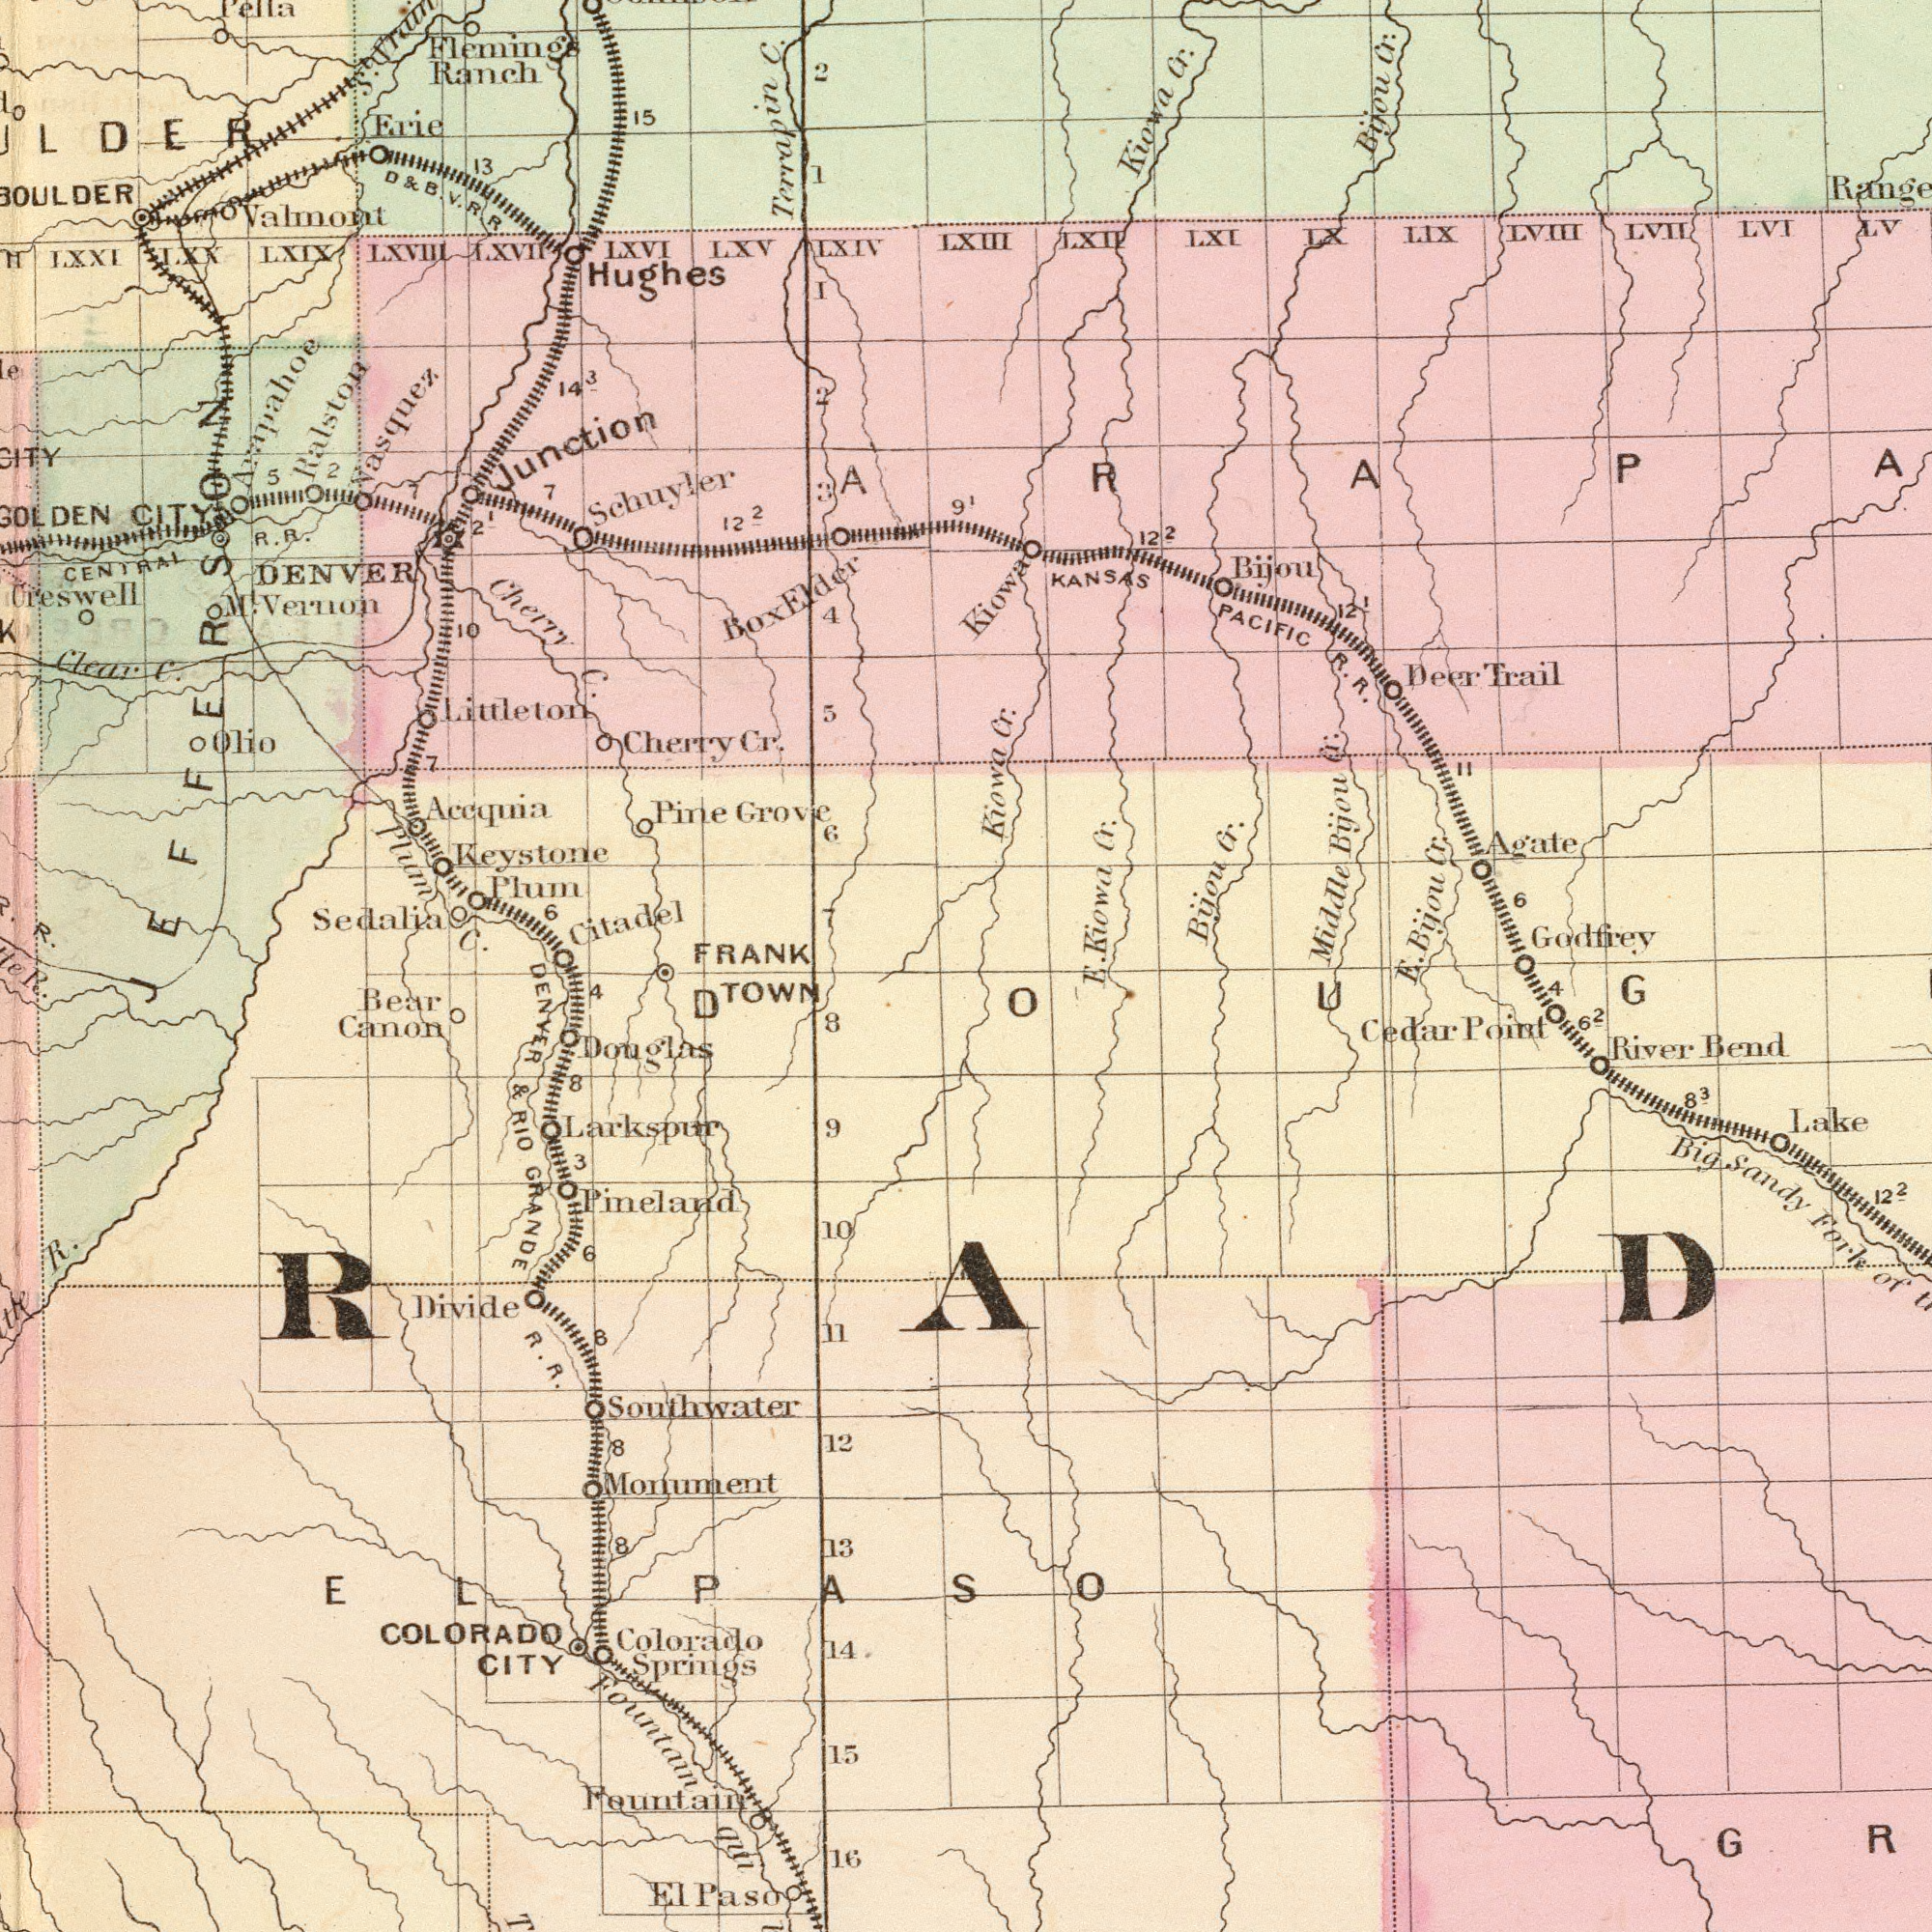What text is shown in the top-right quadrant? 91 Kiowa Cr. Bijou Cr. Bijou Cr. Kiowa Cr. KANSAS PACIFIC R. R. Middle Bijou Cr: Deer Trail LVII LXI Bijou Agate LIX LVIH LV LVI LXII LX Kiowa Cr. Kiowe Godfrey Bijou Cr. 11 122 LXIII 121 6 What text is shown in the bottom-left quadrant? TOWN Pineland Larkspur Bear Canon DENYER & RIO GRANDE R. R. Fountain R. Colorado Springs Monument Fountain aul 16 10 Southwater Divide 14 COLORADO CITY 13 11 8 9 15 El Paso 12 Douglas 4 8 8 R. 8 ELPASO 3 8 6 What text is visible in the lower-right corner? R. R. Cedar Point River Bend Big Sandy Fork of 83 122 Lake 4 62 ###RAD### What text is visible in the upper-left corner? Schuyler Keystone Plum Hughes Flemings Ranch DENVER Ralston Vasquez Acoquia Sedalia Clear C. LXV Erie IXVI Citadel Cherry C. Creswell Pine Grove LXVTII LXXL CITY Terrapin C. LXIX LXIV Cherry Cr. Plum C. 13 Olio LXX FRANK Valmont Junction Littleton 6 CENTRAL R. R. R. 4 122 1 5 15 M. Veruon 143 Pella 6 1O 3 LXVTII JEFFERSON 5 I 2 St. 2 7 7 21 2 Box Elder 2 D & B V. R. R. 